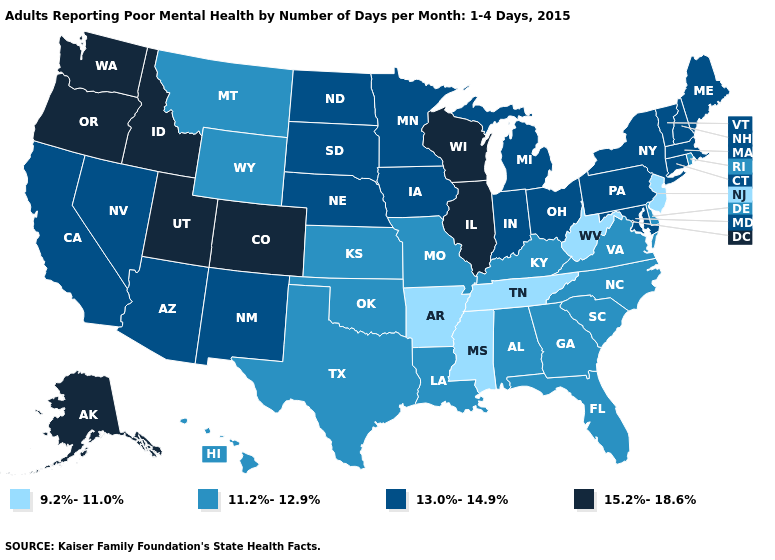Among the states that border Montana , which have the lowest value?
Concise answer only. Wyoming. Does the map have missing data?
Quick response, please. No. What is the value of Utah?
Quick response, please. 15.2%-18.6%. Name the states that have a value in the range 15.2%-18.6%?
Give a very brief answer. Alaska, Colorado, Idaho, Illinois, Oregon, Utah, Washington, Wisconsin. What is the value of Connecticut?
Answer briefly. 13.0%-14.9%. Among the states that border Louisiana , which have the lowest value?
Write a very short answer. Arkansas, Mississippi. Among the states that border Texas , which have the highest value?
Give a very brief answer. New Mexico. What is the value of Florida?
Keep it brief. 11.2%-12.9%. Among the states that border South Carolina , which have the lowest value?
Quick response, please. Georgia, North Carolina. Does Washington have the lowest value in the West?
Short answer required. No. How many symbols are there in the legend?
Short answer required. 4. Which states hav the highest value in the South?
Be succinct. Maryland. Does New York have a lower value than Illinois?
Quick response, please. Yes. What is the value of Wyoming?
Write a very short answer. 11.2%-12.9%. What is the value of Rhode Island?
Keep it brief. 11.2%-12.9%. 